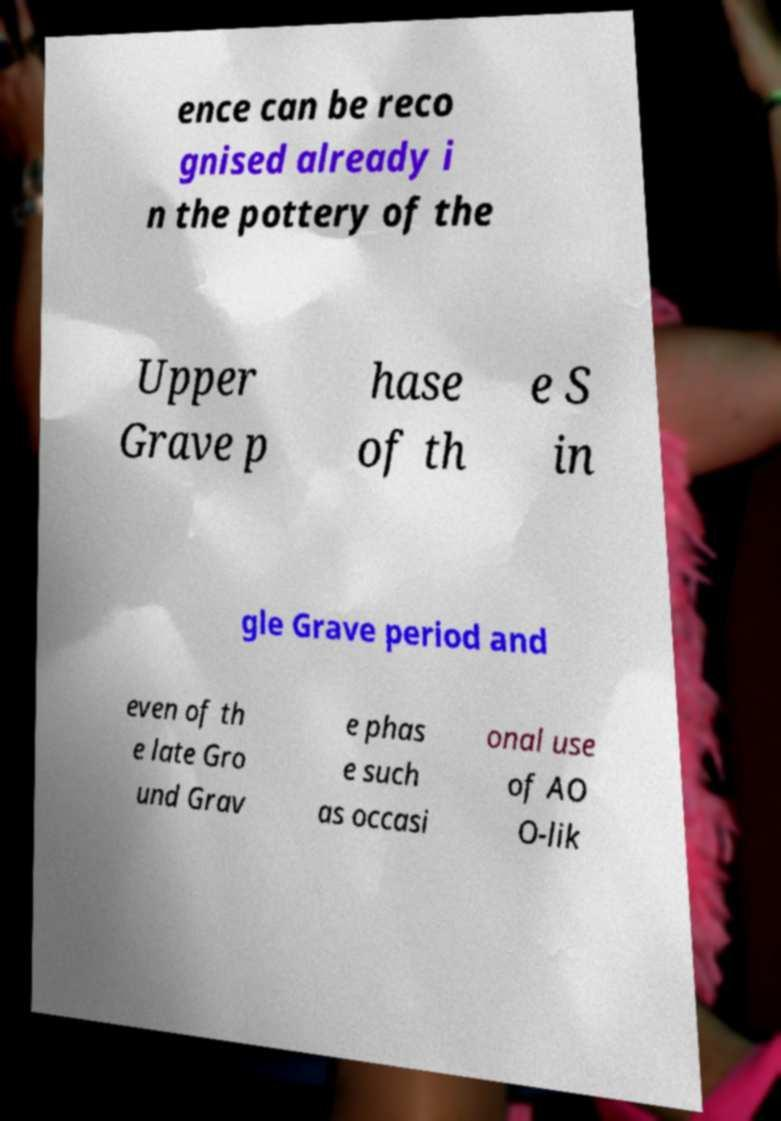Could you extract and type out the text from this image? ence can be reco gnised already i n the pottery of the Upper Grave p hase of th e S in gle Grave period and even of th e late Gro und Grav e phas e such as occasi onal use of AO O-lik 